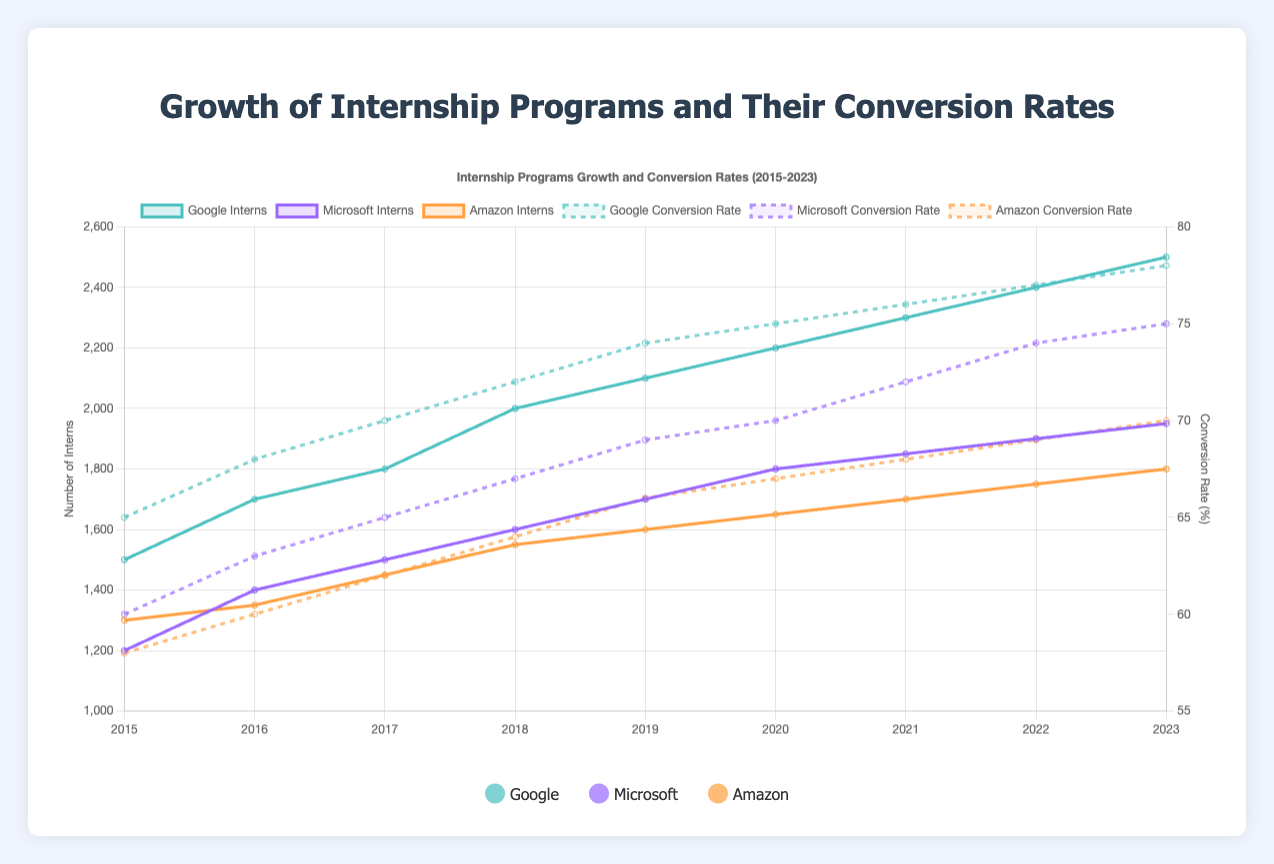What is the title of the chart? The title of the chart is displayed at the top, and it reads "Internship Programs Growth and Conversion Rates (2015-2023)."
Answer: Internship Programs Growth and Conversion Rates (2015-2023) How many data points are there for the year 2020? For the year 2020, there are three data points shown, one for each internship program: Google, Microsoft, and Amazon.
Answer: 3 Which company had the highest conversion rate in 2023? By looking at the dashed lines representing conversion rates, Google had the highest conversion rate in 2023, with 78%.
Answer: Google What is the trend in the number of interns for Google from 2015 to 2023? The solid line representing Google's number of interns shows a consistent upward trend from 1500 in 2015 to 2500 in 2023.
Answer: Upward trend By how much did Microsoft's number of interns increase from 2015 to 2023? In 2015, Microsoft had 1200 interns, and in 2023, it had 1950 interns. The increase is 1950 - 1200 = 750 interns.
Answer: 750 How does Amazon's conversion rate in 2018 compare to its conversion rate in 2023? By comparing the dashed lines for Amazon, we see that its conversion rate was 64% in 2018 and increased to 70% in 2023, a difference of 6%.
Answer: It increased by 6% What is the average conversion rate for Microsoft from 2015 to 2023? The conversion rates for Microsoft over the years are: 60%, 63%, 65%, 67%, 69%, 70%, 72%, 74%, and 75%. Adding these values gives 615, and there are 9 years. So, the average is 615/9 = 68.33%.
Answer: 68.33% Which company had the largest increase in the number of interns from 2015 to 2023? Comparing the increases, Google went from 1500 to 2500 (1000 increase), Microsoft from 1200 to 1950 (750 increase), and Amazon from 1300 to 1800 (500 increase). Google had the largest increase.
Answer: Google Which year saw the highest conversion rate for Amazon? The dashed line representing Amazon's conversion rates shows that the highest point is in 2023, with a conversion rate of 70%.
Answer: 2023 